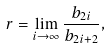<formula> <loc_0><loc_0><loc_500><loc_500>r = \lim _ { i \to \infty } \frac { b _ { 2 i } } { b _ { 2 i + 2 } } ,</formula> 